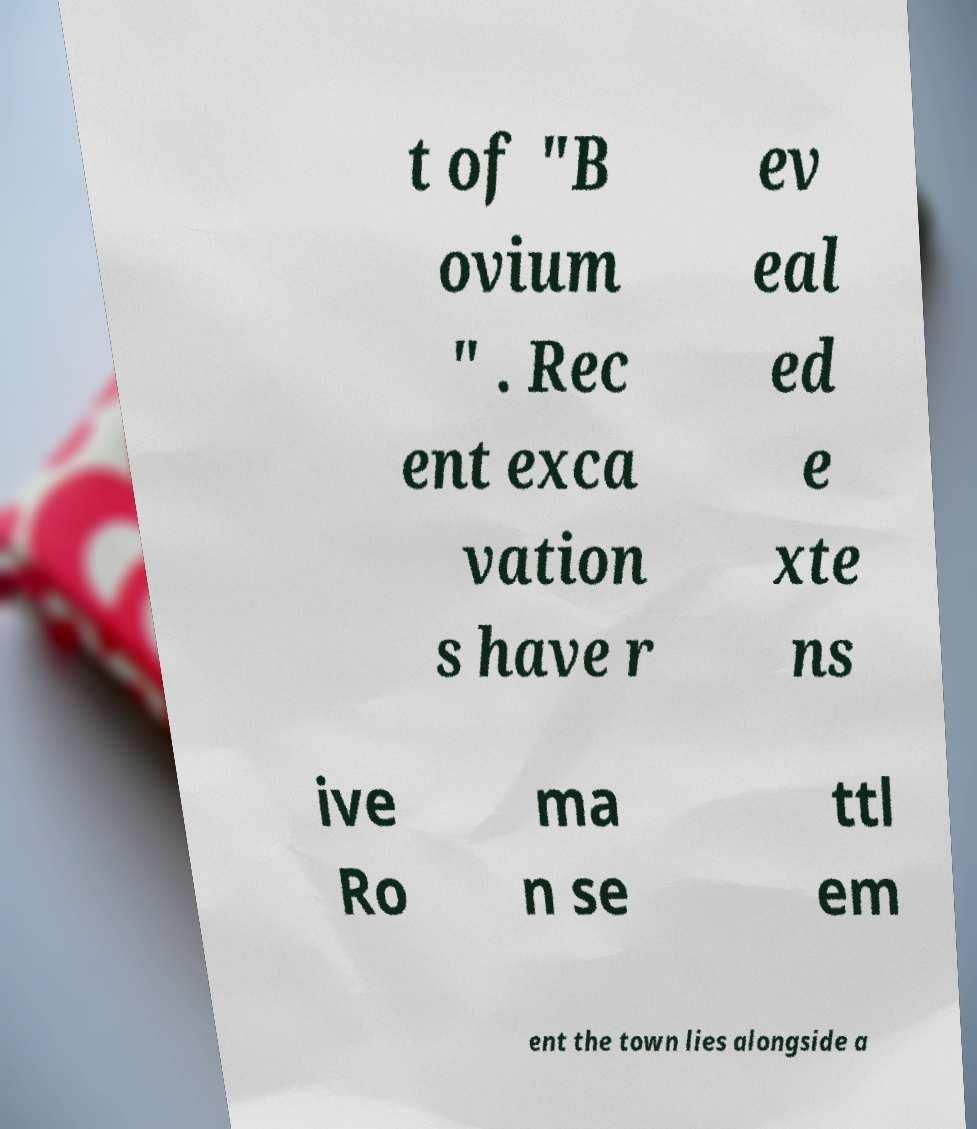Please read and relay the text visible in this image. What does it say? t of "B ovium " . Rec ent exca vation s have r ev eal ed e xte ns ive Ro ma n se ttl em ent the town lies alongside a 